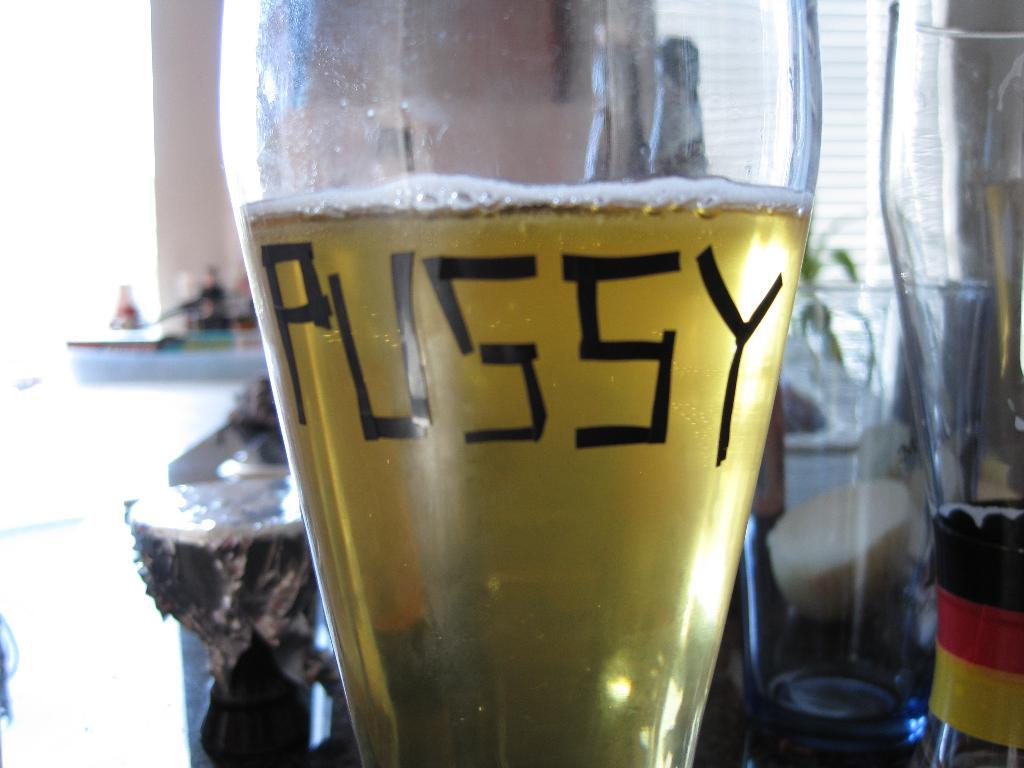<image>
Offer a succinct explanation of the picture presented. a close up of a glass of beer with the word Pussy written on it 